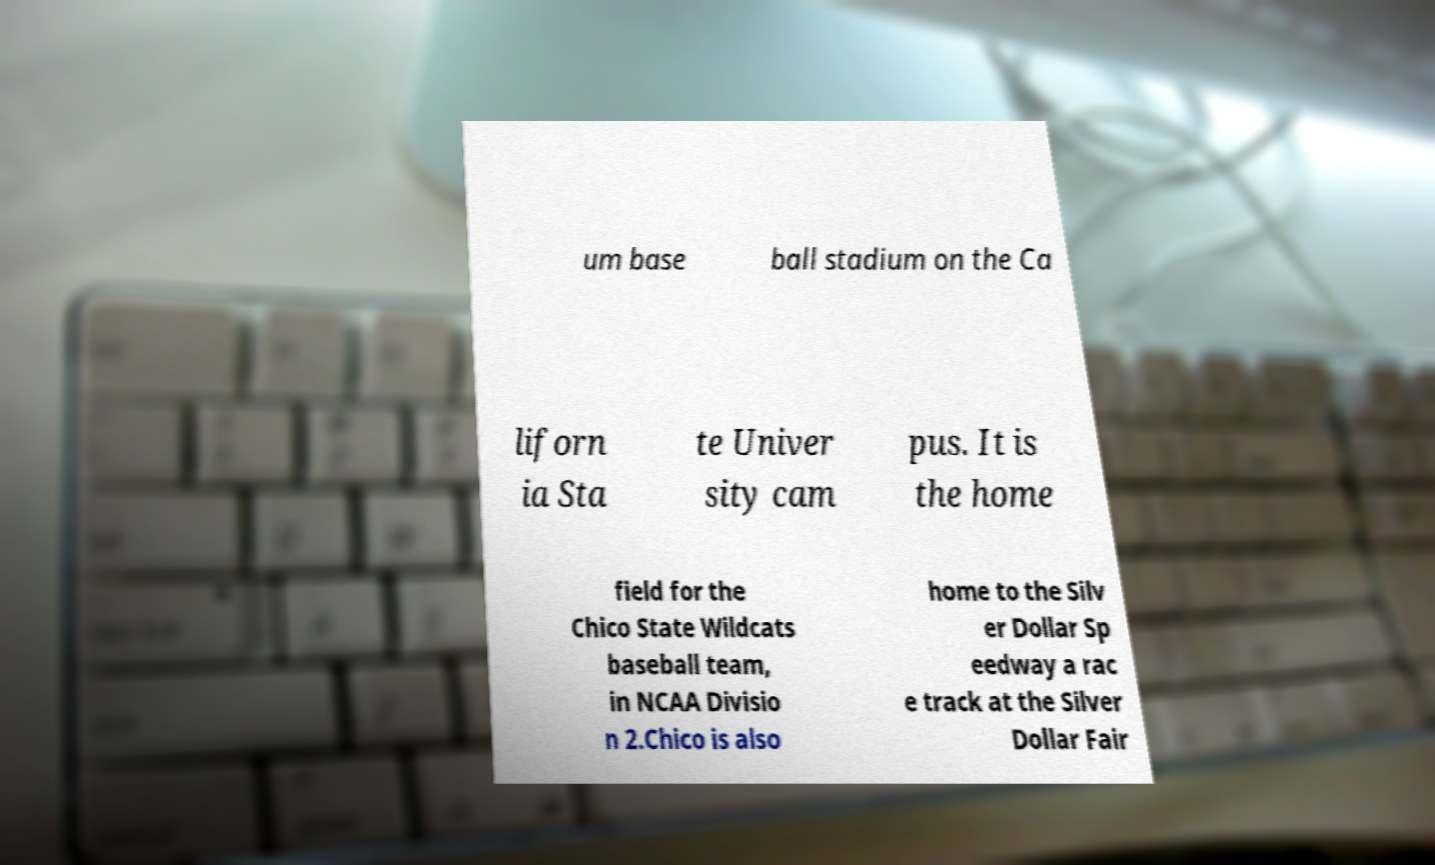Could you extract and type out the text from this image? um base ball stadium on the Ca liforn ia Sta te Univer sity cam pus. It is the home field for the Chico State Wildcats baseball team, in NCAA Divisio n 2.Chico is also home to the Silv er Dollar Sp eedway a rac e track at the Silver Dollar Fair 